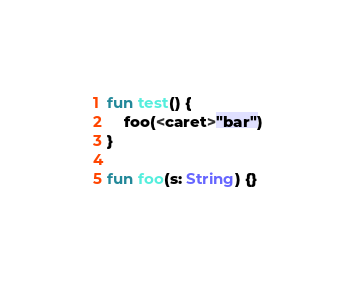<code> <loc_0><loc_0><loc_500><loc_500><_Kotlin_>fun test() {
    foo(<caret>"bar")
}

fun foo(s: String) {}</code> 